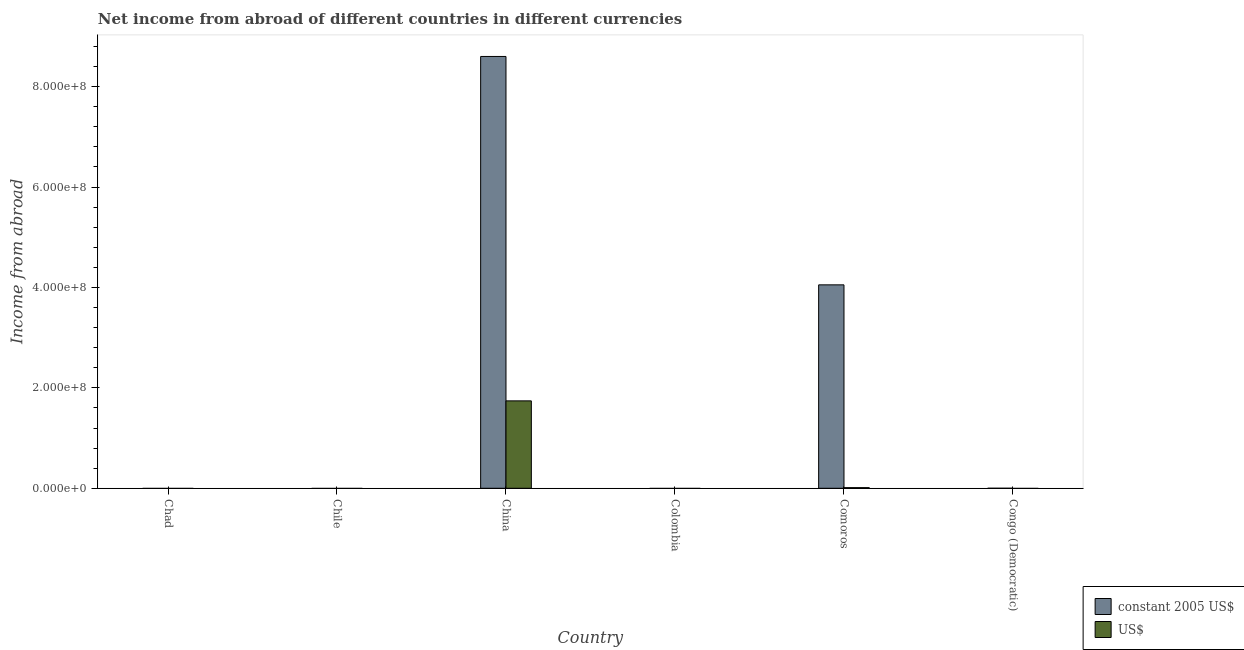How many different coloured bars are there?
Keep it short and to the point. 2. Are the number of bars per tick equal to the number of legend labels?
Make the answer very short. No. What is the label of the 1st group of bars from the left?
Ensure brevity in your answer.  Chad. In how many cases, is the number of bars for a given country not equal to the number of legend labels?
Give a very brief answer. 4. Across all countries, what is the maximum income from abroad in us$?
Give a very brief answer. 1.74e+08. In which country was the income from abroad in us$ maximum?
Ensure brevity in your answer.  China. What is the total income from abroad in us$ in the graph?
Your response must be concise. 1.75e+08. What is the difference between the income from abroad in us$ in China and the income from abroad in constant 2005 us$ in Congo (Democratic)?
Make the answer very short. 1.74e+08. What is the average income from abroad in constant 2005 us$ per country?
Give a very brief answer. 2.11e+08. What is the difference between the income from abroad in us$ and income from abroad in constant 2005 us$ in Comoros?
Give a very brief answer. -4.04e+08. In how many countries, is the income from abroad in constant 2005 us$ greater than 40000000 units?
Keep it short and to the point. 2. What is the difference between the highest and the lowest income from abroad in constant 2005 us$?
Your response must be concise. 8.60e+08. In how many countries, is the income from abroad in constant 2005 us$ greater than the average income from abroad in constant 2005 us$ taken over all countries?
Your answer should be very brief. 2. Is the sum of the income from abroad in us$ in China and Comoros greater than the maximum income from abroad in constant 2005 us$ across all countries?
Ensure brevity in your answer.  No. How many bars are there?
Provide a short and direct response. 4. Are all the bars in the graph horizontal?
Make the answer very short. No. How many countries are there in the graph?
Keep it short and to the point. 6. Does the graph contain grids?
Provide a short and direct response. No. How many legend labels are there?
Provide a succinct answer. 2. What is the title of the graph?
Your answer should be very brief. Net income from abroad of different countries in different currencies. Does "Export" appear as one of the legend labels in the graph?
Your answer should be compact. No. What is the label or title of the X-axis?
Your response must be concise. Country. What is the label or title of the Y-axis?
Ensure brevity in your answer.  Income from abroad. What is the Income from abroad of constant 2005 US$ in Chad?
Offer a very short reply. 0. What is the Income from abroad of constant 2005 US$ in China?
Make the answer very short. 8.60e+08. What is the Income from abroad of US$ in China?
Keep it short and to the point. 1.74e+08. What is the Income from abroad of constant 2005 US$ in Comoros?
Provide a short and direct response. 4.05e+08. What is the Income from abroad in US$ in Comoros?
Offer a very short reply. 1.27e+06. What is the Income from abroad of constant 2005 US$ in Congo (Democratic)?
Give a very brief answer. 0. Across all countries, what is the maximum Income from abroad in constant 2005 US$?
Keep it short and to the point. 8.60e+08. Across all countries, what is the maximum Income from abroad of US$?
Offer a terse response. 1.74e+08. What is the total Income from abroad in constant 2005 US$ in the graph?
Your answer should be very brief. 1.27e+09. What is the total Income from abroad in US$ in the graph?
Give a very brief answer. 1.75e+08. What is the difference between the Income from abroad of constant 2005 US$ in China and that in Comoros?
Make the answer very short. 4.55e+08. What is the difference between the Income from abroad in US$ in China and that in Comoros?
Offer a terse response. 1.73e+08. What is the difference between the Income from abroad in constant 2005 US$ in China and the Income from abroad in US$ in Comoros?
Your answer should be compact. 8.59e+08. What is the average Income from abroad of constant 2005 US$ per country?
Make the answer very short. 2.11e+08. What is the average Income from abroad of US$ per country?
Ensure brevity in your answer.  2.92e+07. What is the difference between the Income from abroad in constant 2005 US$ and Income from abroad in US$ in China?
Provide a short and direct response. 6.86e+08. What is the difference between the Income from abroad of constant 2005 US$ and Income from abroad of US$ in Comoros?
Offer a very short reply. 4.04e+08. What is the ratio of the Income from abroad in constant 2005 US$ in China to that in Comoros?
Provide a succinct answer. 2.12. What is the ratio of the Income from abroad in US$ in China to that in Comoros?
Your answer should be very brief. 137.07. What is the difference between the highest and the lowest Income from abroad of constant 2005 US$?
Provide a succinct answer. 8.60e+08. What is the difference between the highest and the lowest Income from abroad of US$?
Your response must be concise. 1.74e+08. 